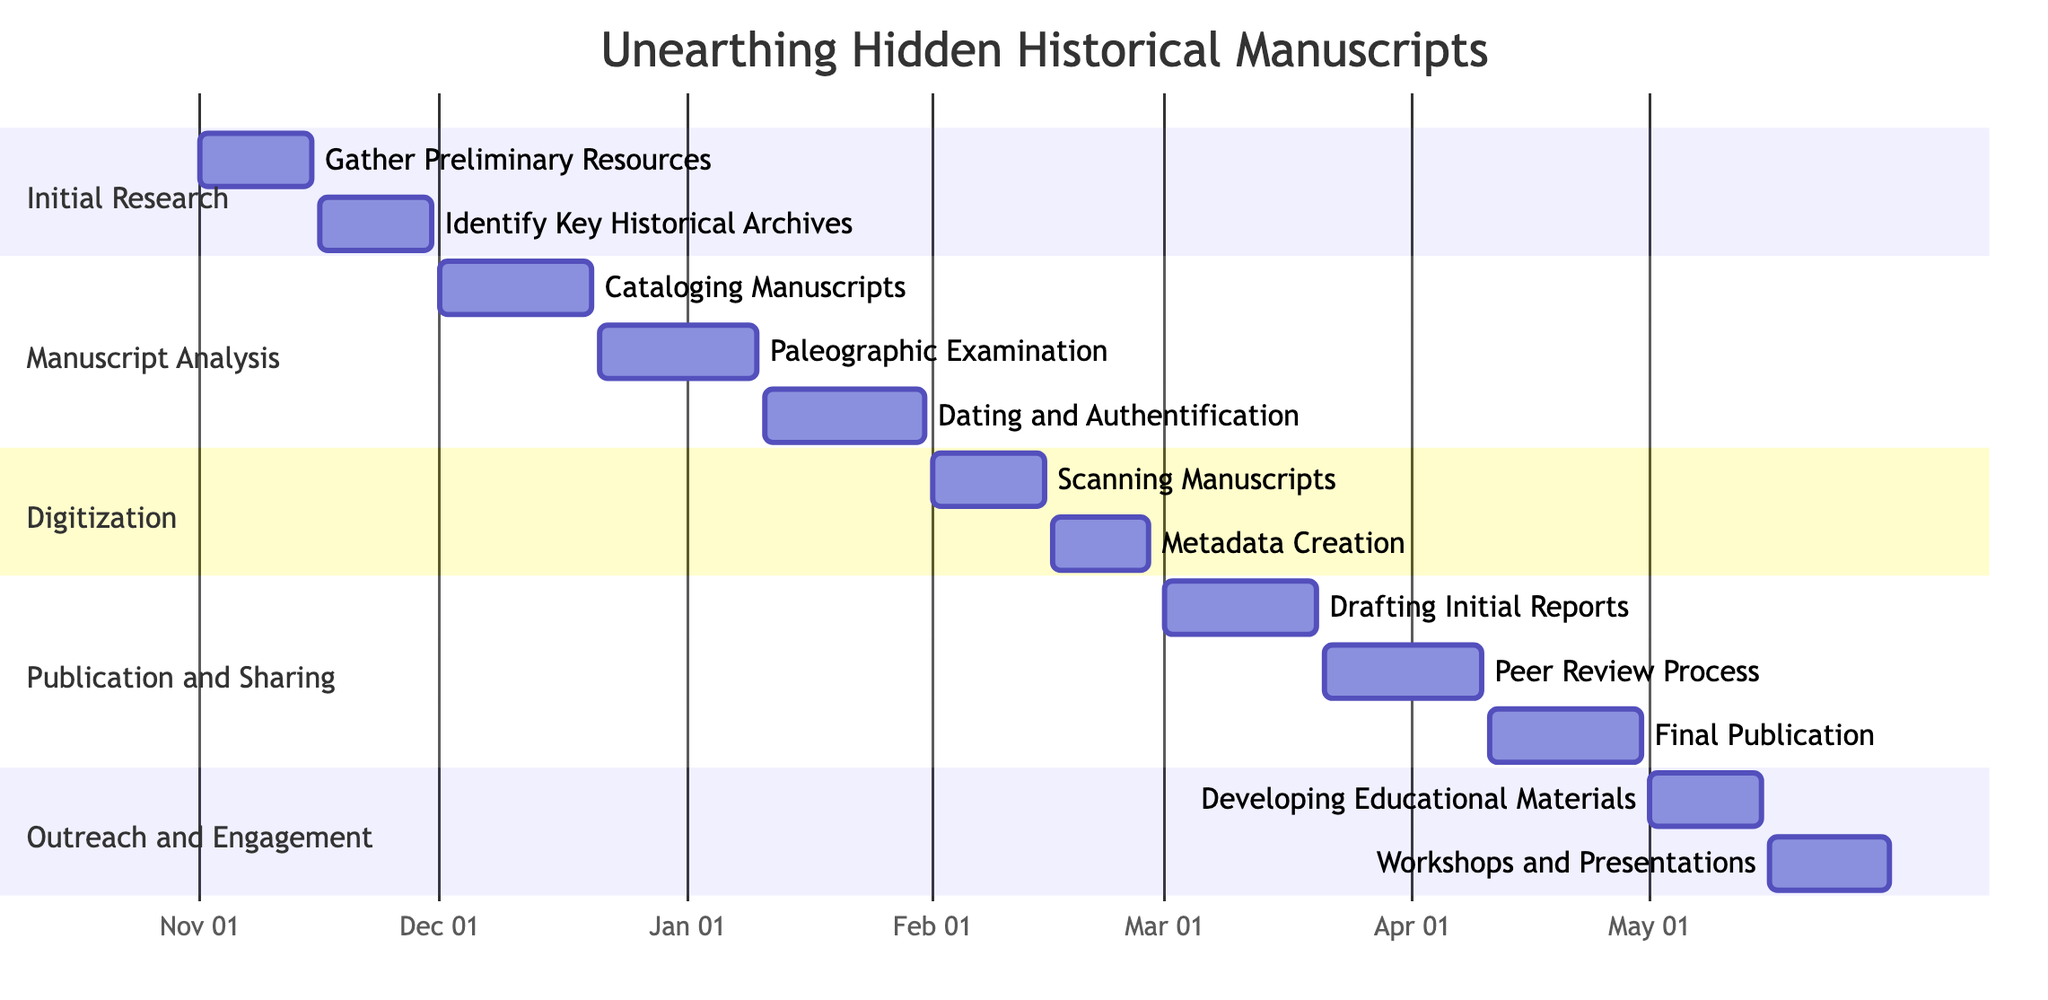What is the duration of the "Initial Research" phase? The "Initial Research" phase includes two milestones: "Gather Preliminary Resources" from November 1 to November 15, and "Identify Key Historical Archives" from November 16 to November 30. The total duration is from the start date of the first milestone to the end date of the second milestone, which is November 1 to November 30.
Answer: 30 days How many milestones are there in the "Digitization" phase? The "Digitization" phase has two milestones: "Scanning Manuscripts" and "Metadata Creation." Counting these gives a total of two milestones.
Answer: 2 Which milestone starts immediately after "Paleographic Examination"? The "Paleographic Examination" milestone ends on January 10, 2024. The next milestone, which starts immediately after, is "Dating and Authentification," beginning on January 11, 2024.
Answer: Dating and Authentification What is the end date of the "Final Publication" milestone? The "Final Publication" milestone clearly shows its end date marked as April 30, 2024.
Answer: April 30, 2024 Determine the total number of phases in the project. The project has five distinct phases: "Initial Research," "Manuscript Analysis," "Digitization," "Publication and Sharing," and "Outreach and Engagement." Counting these gives a total of five phases.
Answer: 5 During which month does the "Peer Review Process" start? The "Peer Review Process" milestone starts on March 21, 2024. Since March is the third month, the reasoning leads to the conclusion that this process starts in March.
Answer: March What are the consecutive milestones during the "Publication and Sharing" phase? The "Publication and Sharing" phase includes three consecutive milestones: "Drafting Initial Reports," "Peer Review Process," and "Final Publication." These milestones occur in the order mentioned.
Answer: Drafting Initial Reports, Peer Review Process, Final Publication Which phase has the earliest starting milestone? The earliest starting milestone is "Gather Preliminary Resources," starting on November 1, 2023, which is part of the "Initial Research" phase. Therefore, the phase with the earliest start is "Initial Research."
Answer: Initial Research 